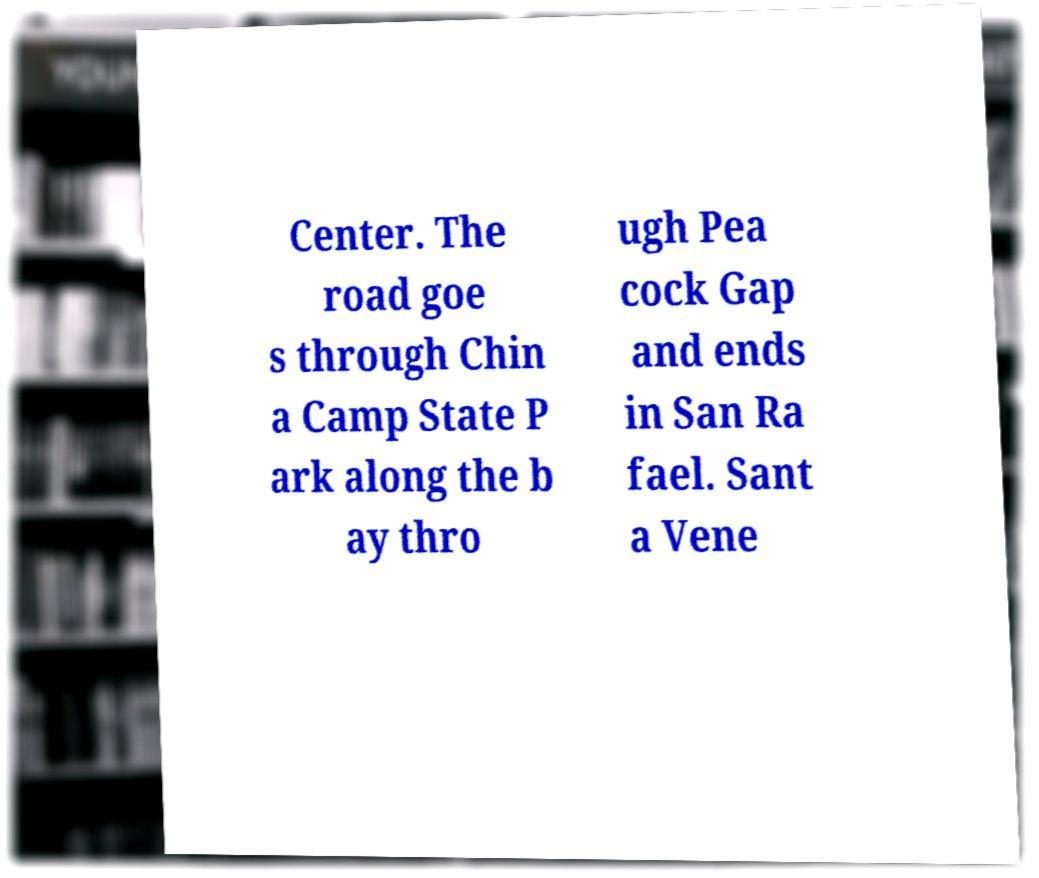Please identify and transcribe the text found in this image. Center. The road goe s through Chin a Camp State P ark along the b ay thro ugh Pea cock Gap and ends in San Ra fael. Sant a Vene 